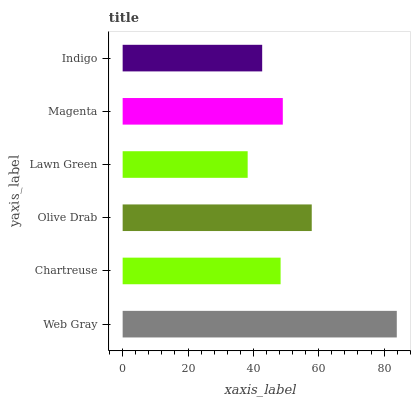Is Lawn Green the minimum?
Answer yes or no. Yes. Is Web Gray the maximum?
Answer yes or no. Yes. Is Chartreuse the minimum?
Answer yes or no. No. Is Chartreuse the maximum?
Answer yes or no. No. Is Web Gray greater than Chartreuse?
Answer yes or no. Yes. Is Chartreuse less than Web Gray?
Answer yes or no. Yes. Is Chartreuse greater than Web Gray?
Answer yes or no. No. Is Web Gray less than Chartreuse?
Answer yes or no. No. Is Magenta the high median?
Answer yes or no. Yes. Is Chartreuse the low median?
Answer yes or no. Yes. Is Indigo the high median?
Answer yes or no. No. Is Olive Drab the low median?
Answer yes or no. No. 